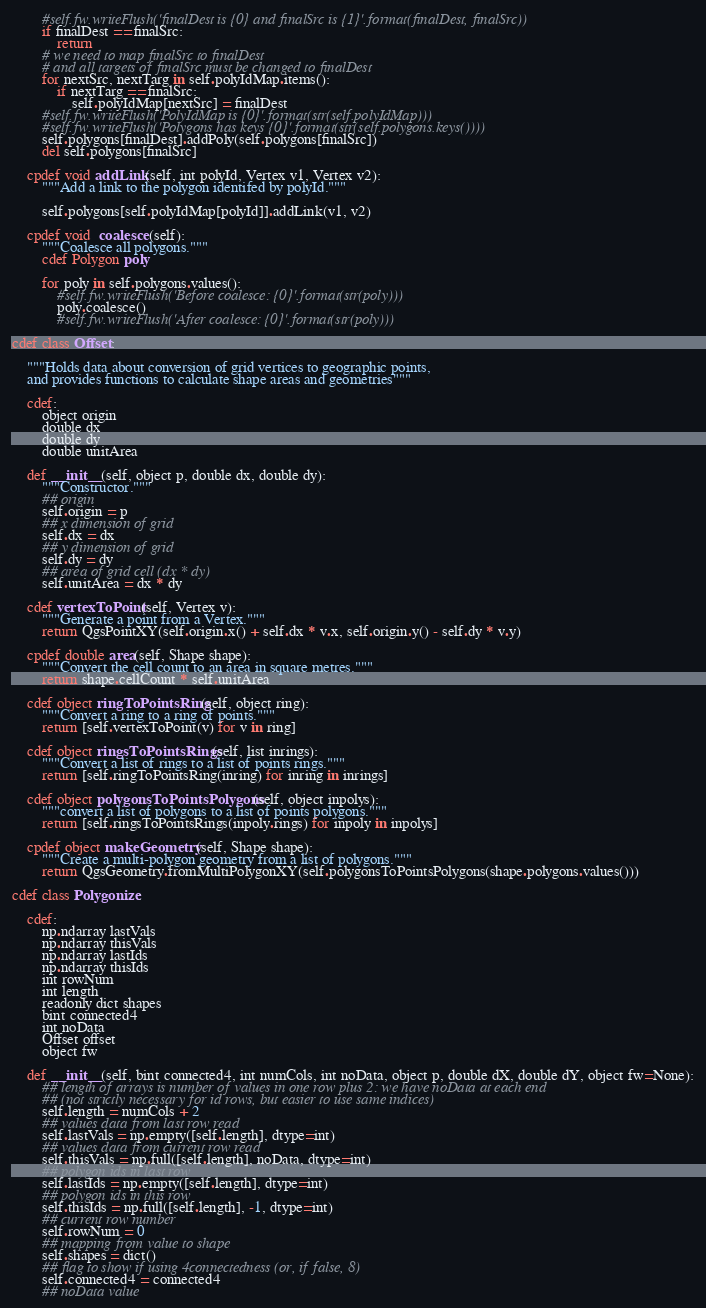<code> <loc_0><loc_0><loc_500><loc_500><_Cython_>        #self.fw.writeFlush('finalDest is {0} and finalSrc is {1}'.format(finalDest, finalSrc))
        if finalDest == finalSrc:
            return
        # we need to map finalSrc to finalDest
        # and all targets of finalSrc must be changed to finalDest
        for nextSrc, nextTarg in self.polyIdMap.items():
            if nextTarg == finalSrc:
                self.polyIdMap[nextSrc] = finalDest
        #self.fw.writeFlush('PolyIdMap is {0}'.format(str(self.polyIdMap)))
        #self.fw.writeFlush('Polygons has keys {0}'.format(str(self.polygons.keys())))
        self.polygons[finalDest].addPoly(self.polygons[finalSrc])
        del self.polygons[finalSrc]   
        
    cpdef void addLink(self, int polyId, Vertex v1, Vertex v2):
        """Add a link to the polygon identifed by polyId."""
        
        self.polygons[self.polyIdMap[polyId]].addLink(v1, v2)  
        
    cpdef void  coalesce(self):     
        """Coalesce all polygons."""
        cdef Polygon poly
        
        for poly in self.polygons.values():
            #self.fw.writeFlush('Before coalesce: {0}'.format(str(poly)))
            poly.coalesce()
            #self.fw.writeFlush('After coalesce: {0}'.format(str(poly)))
                
cdef class Offset:
        
    """Holds data about conversion of grid vertices to geographic points, 
    and provides functions to calculate shape areas and geometries"""
    
    cdef:
        object origin
        double dx
        double dy
        double unitArea
        
    def __init__(self, object p, double dx, double dy):
        """Constructor."""
        ## origin
        self.origin = p
        ## x dimension of grid
        self.dx = dx
        ## y dimension of grid
        self.dy = dy
        ## area of grid cell (dx * dy)
        self.unitArea = dx * dy
        
    cdef vertexToPoint(self, Vertex v):
        """Generate a point from a Vertex."""
        return QgsPointXY(self.origin.x() + self.dx * v.x, self.origin.y() - self.dy * v.y)
        
    cpdef double area(self, Shape shape):
        """Convert the cell count to an area in square metres."""
        return shape.cellCount * self.unitArea
        
    cdef object ringToPointsRing(self, object ring):
        """Convert a ring to a ring of points."""
        return [self.vertexToPoint(v) for v in ring]
    
    cdef object ringsToPointsRings(self, list inrings):
        """Convert a list of rings to a list of points rings."""
        return [self.ringToPointsRing(inring) for inring in inrings]
    
    cdef object polygonsToPointsPolygons(self, object inpolys):
        """convert a list of polygons to a list of points polygons."""
        return [self.ringsToPointsRings(inpoly.rings) for inpoly in inpolys]
        
    cpdef object makeGeometry(self, Shape shape):
        """Create a multi-polygon geometry from a list of polygons."""
        return QgsGeometry.fromMultiPolygonXY(self.polygonsToPointsPolygons(shape.polygons.values()))

cdef class Polygonize:

    cdef:
        np.ndarray lastVals
        np.ndarray thisVals
        np.ndarray lastIds
        np.ndarray thisIds
        int rowNum
        int length
        readonly dict shapes
        bint connected4
        int noData
        Offset offset
        object fw
        
    def __init__(self, bint connected4, int numCols, int noData, object p, double dX, double dY, object fw=None):
        ## length of arrays is number of values in one row plus 2: we have noData at each end
        ## (not strictly necessary for id rows, but easier to use same indices)
        self.length = numCols + 2
        ## values data from last row read
        self.lastVals = np.empty([self.length], dtype=int)
        ## values data from current row read
        self.thisVals = np.full([self.length], noData, dtype=int)
        ## polygon ids in last row
        self.lastIds = np.empty([self.length], dtype=int)
        ## polygon ids in this row
        self.thisIds = np.full([self.length], -1, dtype=int)
        ## current row number
        self.rowNum = 0
        ## mapping from value to shape
        self.shapes = dict()
        ## flag to show if using 4connectedness (or, if false, 8)
        self.connected4 = connected4
        ## noData value</code> 